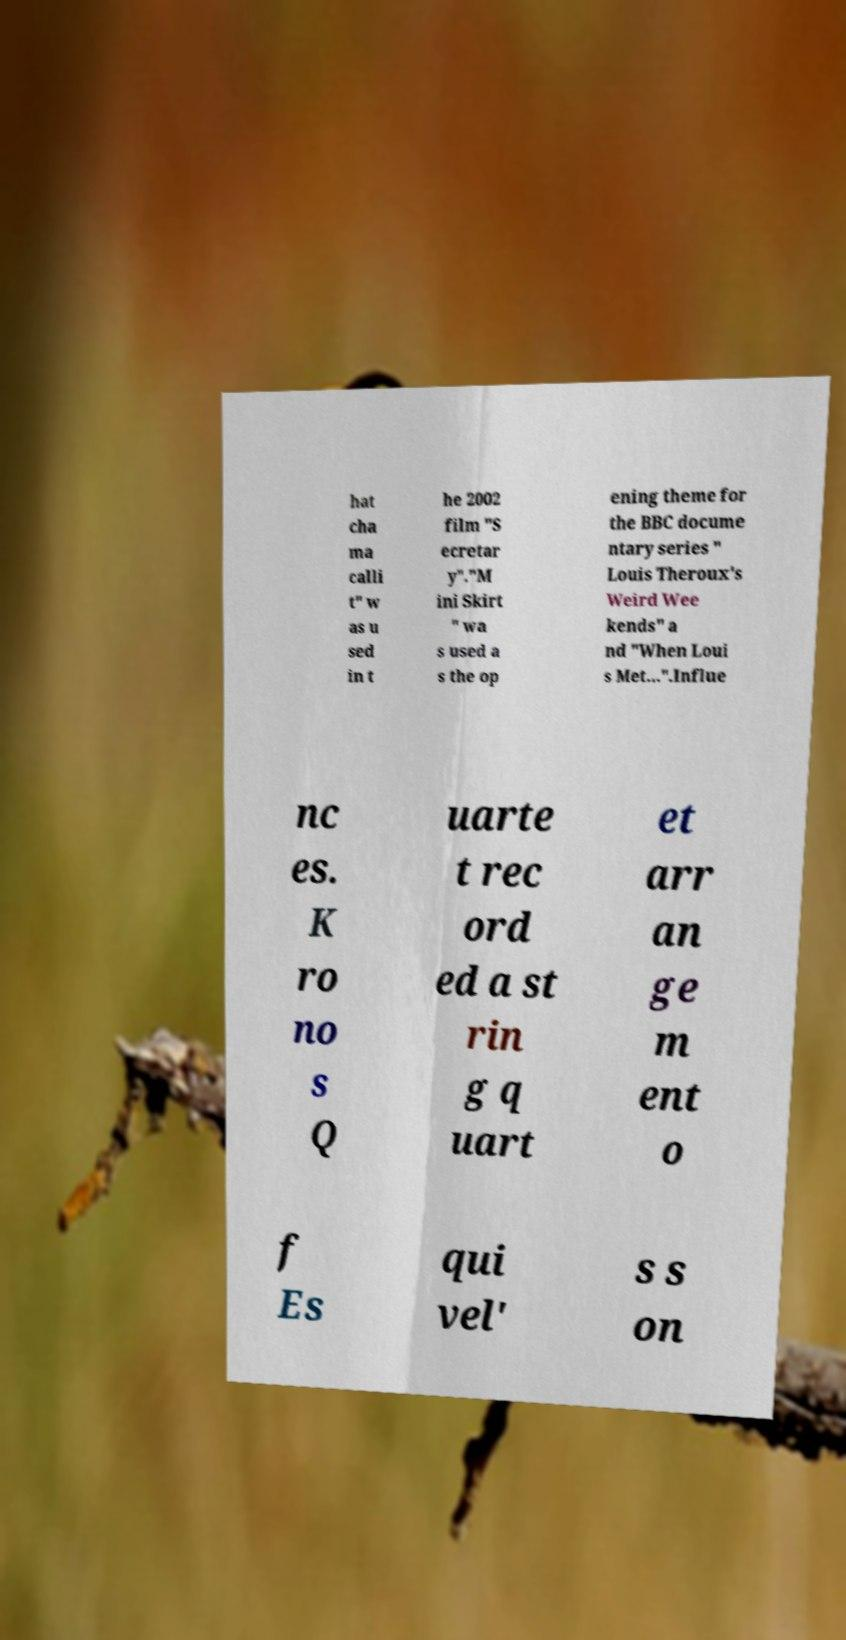Please identify and transcribe the text found in this image. hat cha ma calli t" w as u sed in t he 2002 film "S ecretar y"."M ini Skirt " wa s used a s the op ening theme for the BBC docume ntary series " Louis Theroux's Weird Wee kends" a nd "When Loui s Met...".Influe nc es. K ro no s Q uarte t rec ord ed a st rin g q uart et arr an ge m ent o f Es qui vel' s s on 